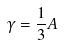<formula> <loc_0><loc_0><loc_500><loc_500>\gamma = \frac { 1 } { 3 } A</formula> 